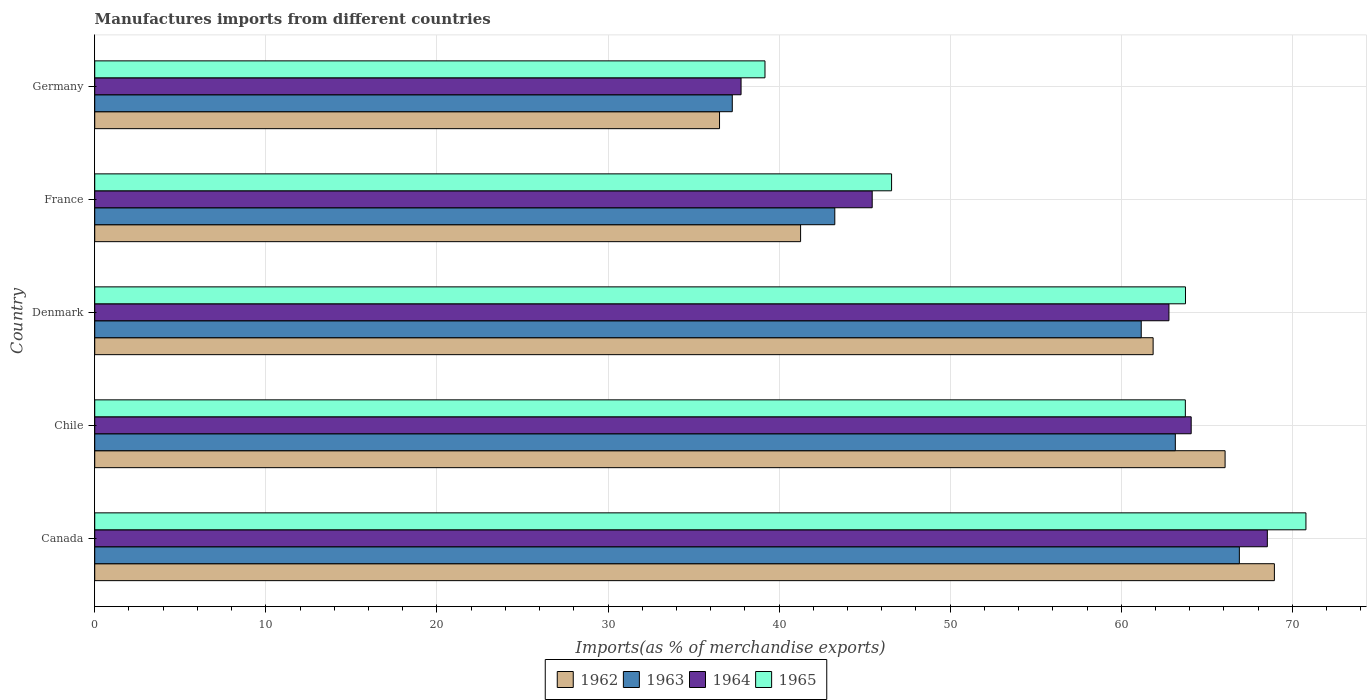How many different coloured bars are there?
Your answer should be compact. 4. Are the number of bars per tick equal to the number of legend labels?
Give a very brief answer. Yes. What is the percentage of imports to different countries in 1963 in Chile?
Your answer should be very brief. 63.16. Across all countries, what is the maximum percentage of imports to different countries in 1962?
Your answer should be very brief. 68.95. Across all countries, what is the minimum percentage of imports to different countries in 1963?
Your answer should be very brief. 37.26. In which country was the percentage of imports to different countries in 1964 minimum?
Offer a very short reply. Germany. What is the total percentage of imports to different countries in 1964 in the graph?
Your response must be concise. 278.63. What is the difference between the percentage of imports to different countries in 1962 in France and that in Germany?
Offer a terse response. 4.74. What is the difference between the percentage of imports to different countries in 1964 in France and the percentage of imports to different countries in 1963 in Denmark?
Your answer should be compact. -15.72. What is the average percentage of imports to different countries in 1964 per country?
Provide a short and direct response. 55.73. What is the difference between the percentage of imports to different countries in 1962 and percentage of imports to different countries in 1965 in France?
Give a very brief answer. -5.32. In how many countries, is the percentage of imports to different countries in 1964 greater than 70 %?
Your response must be concise. 0. What is the ratio of the percentage of imports to different countries in 1964 in Denmark to that in Germany?
Your answer should be compact. 1.66. What is the difference between the highest and the second highest percentage of imports to different countries in 1963?
Give a very brief answer. 3.74. What is the difference between the highest and the lowest percentage of imports to different countries in 1962?
Give a very brief answer. 32.43. In how many countries, is the percentage of imports to different countries in 1964 greater than the average percentage of imports to different countries in 1964 taken over all countries?
Give a very brief answer. 3. What does the 3rd bar from the top in France represents?
Ensure brevity in your answer.  1963. What does the 4th bar from the bottom in Denmark represents?
Your answer should be very brief. 1965. How many bars are there?
Offer a very short reply. 20. How many countries are there in the graph?
Provide a short and direct response. 5. Are the values on the major ticks of X-axis written in scientific E-notation?
Provide a succinct answer. No. What is the title of the graph?
Your answer should be very brief. Manufactures imports from different countries. Does "1991" appear as one of the legend labels in the graph?
Offer a very short reply. No. What is the label or title of the X-axis?
Ensure brevity in your answer.  Imports(as % of merchandise exports). What is the label or title of the Y-axis?
Offer a terse response. Country. What is the Imports(as % of merchandise exports) of 1962 in Canada?
Ensure brevity in your answer.  68.95. What is the Imports(as % of merchandise exports) of 1963 in Canada?
Offer a very short reply. 66.9. What is the Imports(as % of merchandise exports) in 1964 in Canada?
Your response must be concise. 68.54. What is the Imports(as % of merchandise exports) of 1965 in Canada?
Ensure brevity in your answer.  70.79. What is the Imports(as % of merchandise exports) in 1962 in Chile?
Provide a succinct answer. 66.07. What is the Imports(as % of merchandise exports) of 1963 in Chile?
Keep it short and to the point. 63.16. What is the Imports(as % of merchandise exports) in 1964 in Chile?
Your answer should be very brief. 64.09. What is the Imports(as % of merchandise exports) of 1965 in Chile?
Your answer should be compact. 63.74. What is the Imports(as % of merchandise exports) in 1962 in Denmark?
Ensure brevity in your answer.  61.86. What is the Imports(as % of merchandise exports) in 1963 in Denmark?
Make the answer very short. 61.17. What is the Imports(as % of merchandise exports) in 1964 in Denmark?
Your answer should be compact. 62.79. What is the Imports(as % of merchandise exports) in 1965 in Denmark?
Keep it short and to the point. 63.75. What is the Imports(as % of merchandise exports) in 1962 in France?
Ensure brevity in your answer.  41.26. What is the Imports(as % of merchandise exports) of 1963 in France?
Provide a succinct answer. 43.26. What is the Imports(as % of merchandise exports) in 1964 in France?
Your response must be concise. 45.44. What is the Imports(as % of merchandise exports) in 1965 in France?
Ensure brevity in your answer.  46.57. What is the Imports(as % of merchandise exports) in 1962 in Germany?
Offer a terse response. 36.52. What is the Imports(as % of merchandise exports) of 1963 in Germany?
Offer a very short reply. 37.26. What is the Imports(as % of merchandise exports) in 1964 in Germany?
Your answer should be compact. 37.78. What is the Imports(as % of merchandise exports) of 1965 in Germany?
Give a very brief answer. 39.18. Across all countries, what is the maximum Imports(as % of merchandise exports) in 1962?
Your answer should be compact. 68.95. Across all countries, what is the maximum Imports(as % of merchandise exports) of 1963?
Your answer should be very brief. 66.9. Across all countries, what is the maximum Imports(as % of merchandise exports) in 1964?
Your response must be concise. 68.54. Across all countries, what is the maximum Imports(as % of merchandise exports) of 1965?
Give a very brief answer. 70.79. Across all countries, what is the minimum Imports(as % of merchandise exports) in 1962?
Your response must be concise. 36.52. Across all countries, what is the minimum Imports(as % of merchandise exports) of 1963?
Your response must be concise. 37.26. Across all countries, what is the minimum Imports(as % of merchandise exports) of 1964?
Keep it short and to the point. 37.78. Across all countries, what is the minimum Imports(as % of merchandise exports) in 1965?
Offer a terse response. 39.18. What is the total Imports(as % of merchandise exports) in 1962 in the graph?
Give a very brief answer. 274.65. What is the total Imports(as % of merchandise exports) of 1963 in the graph?
Your answer should be compact. 271.75. What is the total Imports(as % of merchandise exports) in 1964 in the graph?
Provide a succinct answer. 278.63. What is the total Imports(as % of merchandise exports) in 1965 in the graph?
Offer a terse response. 284.04. What is the difference between the Imports(as % of merchandise exports) of 1962 in Canada and that in Chile?
Your response must be concise. 2.88. What is the difference between the Imports(as % of merchandise exports) in 1963 in Canada and that in Chile?
Ensure brevity in your answer.  3.74. What is the difference between the Imports(as % of merchandise exports) in 1964 in Canada and that in Chile?
Ensure brevity in your answer.  4.45. What is the difference between the Imports(as % of merchandise exports) of 1965 in Canada and that in Chile?
Offer a terse response. 7.05. What is the difference between the Imports(as % of merchandise exports) of 1962 in Canada and that in Denmark?
Offer a terse response. 7.09. What is the difference between the Imports(as % of merchandise exports) of 1963 in Canada and that in Denmark?
Provide a short and direct response. 5.74. What is the difference between the Imports(as % of merchandise exports) of 1964 in Canada and that in Denmark?
Keep it short and to the point. 5.75. What is the difference between the Imports(as % of merchandise exports) of 1965 in Canada and that in Denmark?
Your answer should be compact. 7.04. What is the difference between the Imports(as % of merchandise exports) of 1962 in Canada and that in France?
Keep it short and to the point. 27.69. What is the difference between the Imports(as % of merchandise exports) in 1963 in Canada and that in France?
Provide a succinct answer. 23.65. What is the difference between the Imports(as % of merchandise exports) of 1964 in Canada and that in France?
Offer a terse response. 23.1. What is the difference between the Imports(as % of merchandise exports) of 1965 in Canada and that in France?
Your response must be concise. 24.22. What is the difference between the Imports(as % of merchandise exports) of 1962 in Canada and that in Germany?
Make the answer very short. 32.43. What is the difference between the Imports(as % of merchandise exports) in 1963 in Canada and that in Germany?
Your answer should be very brief. 29.64. What is the difference between the Imports(as % of merchandise exports) in 1964 in Canada and that in Germany?
Provide a succinct answer. 30.76. What is the difference between the Imports(as % of merchandise exports) in 1965 in Canada and that in Germany?
Offer a terse response. 31.62. What is the difference between the Imports(as % of merchandise exports) in 1962 in Chile and that in Denmark?
Your response must be concise. 4.21. What is the difference between the Imports(as % of merchandise exports) in 1963 in Chile and that in Denmark?
Ensure brevity in your answer.  1.99. What is the difference between the Imports(as % of merchandise exports) of 1964 in Chile and that in Denmark?
Offer a terse response. 1.3. What is the difference between the Imports(as % of merchandise exports) in 1965 in Chile and that in Denmark?
Your answer should be very brief. -0.01. What is the difference between the Imports(as % of merchandise exports) of 1962 in Chile and that in France?
Provide a succinct answer. 24.81. What is the difference between the Imports(as % of merchandise exports) in 1963 in Chile and that in France?
Ensure brevity in your answer.  19.9. What is the difference between the Imports(as % of merchandise exports) in 1964 in Chile and that in France?
Your response must be concise. 18.64. What is the difference between the Imports(as % of merchandise exports) of 1965 in Chile and that in France?
Your answer should be very brief. 17.17. What is the difference between the Imports(as % of merchandise exports) of 1962 in Chile and that in Germany?
Provide a short and direct response. 29.55. What is the difference between the Imports(as % of merchandise exports) in 1963 in Chile and that in Germany?
Keep it short and to the point. 25.89. What is the difference between the Imports(as % of merchandise exports) of 1964 in Chile and that in Germany?
Ensure brevity in your answer.  26.31. What is the difference between the Imports(as % of merchandise exports) in 1965 in Chile and that in Germany?
Ensure brevity in your answer.  24.57. What is the difference between the Imports(as % of merchandise exports) of 1962 in Denmark and that in France?
Ensure brevity in your answer.  20.61. What is the difference between the Imports(as % of merchandise exports) of 1963 in Denmark and that in France?
Provide a short and direct response. 17.91. What is the difference between the Imports(as % of merchandise exports) in 1964 in Denmark and that in France?
Keep it short and to the point. 17.34. What is the difference between the Imports(as % of merchandise exports) in 1965 in Denmark and that in France?
Provide a short and direct response. 17.18. What is the difference between the Imports(as % of merchandise exports) of 1962 in Denmark and that in Germany?
Offer a terse response. 25.34. What is the difference between the Imports(as % of merchandise exports) of 1963 in Denmark and that in Germany?
Keep it short and to the point. 23.9. What is the difference between the Imports(as % of merchandise exports) in 1964 in Denmark and that in Germany?
Your answer should be very brief. 25.01. What is the difference between the Imports(as % of merchandise exports) in 1965 in Denmark and that in Germany?
Provide a succinct answer. 24.58. What is the difference between the Imports(as % of merchandise exports) of 1962 in France and that in Germany?
Your response must be concise. 4.74. What is the difference between the Imports(as % of merchandise exports) in 1963 in France and that in Germany?
Offer a terse response. 5.99. What is the difference between the Imports(as % of merchandise exports) in 1964 in France and that in Germany?
Make the answer very short. 7.67. What is the difference between the Imports(as % of merchandise exports) in 1965 in France and that in Germany?
Keep it short and to the point. 7.4. What is the difference between the Imports(as % of merchandise exports) of 1962 in Canada and the Imports(as % of merchandise exports) of 1963 in Chile?
Keep it short and to the point. 5.79. What is the difference between the Imports(as % of merchandise exports) of 1962 in Canada and the Imports(as % of merchandise exports) of 1964 in Chile?
Offer a terse response. 4.86. What is the difference between the Imports(as % of merchandise exports) in 1962 in Canada and the Imports(as % of merchandise exports) in 1965 in Chile?
Offer a very short reply. 5.21. What is the difference between the Imports(as % of merchandise exports) in 1963 in Canada and the Imports(as % of merchandise exports) in 1964 in Chile?
Your answer should be very brief. 2.82. What is the difference between the Imports(as % of merchandise exports) in 1963 in Canada and the Imports(as % of merchandise exports) in 1965 in Chile?
Your answer should be very brief. 3.16. What is the difference between the Imports(as % of merchandise exports) in 1964 in Canada and the Imports(as % of merchandise exports) in 1965 in Chile?
Keep it short and to the point. 4.79. What is the difference between the Imports(as % of merchandise exports) in 1962 in Canada and the Imports(as % of merchandise exports) in 1963 in Denmark?
Provide a short and direct response. 7.78. What is the difference between the Imports(as % of merchandise exports) of 1962 in Canada and the Imports(as % of merchandise exports) of 1964 in Denmark?
Provide a short and direct response. 6.16. What is the difference between the Imports(as % of merchandise exports) of 1962 in Canada and the Imports(as % of merchandise exports) of 1965 in Denmark?
Offer a terse response. 5.2. What is the difference between the Imports(as % of merchandise exports) in 1963 in Canada and the Imports(as % of merchandise exports) in 1964 in Denmark?
Provide a short and direct response. 4.12. What is the difference between the Imports(as % of merchandise exports) of 1963 in Canada and the Imports(as % of merchandise exports) of 1965 in Denmark?
Your response must be concise. 3.15. What is the difference between the Imports(as % of merchandise exports) in 1964 in Canada and the Imports(as % of merchandise exports) in 1965 in Denmark?
Your answer should be very brief. 4.78. What is the difference between the Imports(as % of merchandise exports) in 1962 in Canada and the Imports(as % of merchandise exports) in 1963 in France?
Provide a succinct answer. 25.69. What is the difference between the Imports(as % of merchandise exports) of 1962 in Canada and the Imports(as % of merchandise exports) of 1964 in France?
Ensure brevity in your answer.  23.51. What is the difference between the Imports(as % of merchandise exports) in 1962 in Canada and the Imports(as % of merchandise exports) in 1965 in France?
Your response must be concise. 22.38. What is the difference between the Imports(as % of merchandise exports) of 1963 in Canada and the Imports(as % of merchandise exports) of 1964 in France?
Give a very brief answer. 21.46. What is the difference between the Imports(as % of merchandise exports) of 1963 in Canada and the Imports(as % of merchandise exports) of 1965 in France?
Provide a succinct answer. 20.33. What is the difference between the Imports(as % of merchandise exports) of 1964 in Canada and the Imports(as % of merchandise exports) of 1965 in France?
Your answer should be very brief. 21.96. What is the difference between the Imports(as % of merchandise exports) in 1962 in Canada and the Imports(as % of merchandise exports) in 1963 in Germany?
Your answer should be very brief. 31.69. What is the difference between the Imports(as % of merchandise exports) in 1962 in Canada and the Imports(as % of merchandise exports) in 1964 in Germany?
Provide a short and direct response. 31.17. What is the difference between the Imports(as % of merchandise exports) of 1962 in Canada and the Imports(as % of merchandise exports) of 1965 in Germany?
Your response must be concise. 29.77. What is the difference between the Imports(as % of merchandise exports) in 1963 in Canada and the Imports(as % of merchandise exports) in 1964 in Germany?
Make the answer very short. 29.13. What is the difference between the Imports(as % of merchandise exports) of 1963 in Canada and the Imports(as % of merchandise exports) of 1965 in Germany?
Ensure brevity in your answer.  27.73. What is the difference between the Imports(as % of merchandise exports) of 1964 in Canada and the Imports(as % of merchandise exports) of 1965 in Germany?
Your answer should be very brief. 29.36. What is the difference between the Imports(as % of merchandise exports) of 1962 in Chile and the Imports(as % of merchandise exports) of 1963 in Denmark?
Your answer should be compact. 4.9. What is the difference between the Imports(as % of merchandise exports) in 1962 in Chile and the Imports(as % of merchandise exports) in 1964 in Denmark?
Offer a terse response. 3.28. What is the difference between the Imports(as % of merchandise exports) in 1962 in Chile and the Imports(as % of merchandise exports) in 1965 in Denmark?
Offer a terse response. 2.31. What is the difference between the Imports(as % of merchandise exports) in 1963 in Chile and the Imports(as % of merchandise exports) in 1964 in Denmark?
Provide a succinct answer. 0.37. What is the difference between the Imports(as % of merchandise exports) of 1963 in Chile and the Imports(as % of merchandise exports) of 1965 in Denmark?
Provide a short and direct response. -0.59. What is the difference between the Imports(as % of merchandise exports) of 1964 in Chile and the Imports(as % of merchandise exports) of 1965 in Denmark?
Your response must be concise. 0.33. What is the difference between the Imports(as % of merchandise exports) of 1962 in Chile and the Imports(as % of merchandise exports) of 1963 in France?
Your answer should be compact. 22.81. What is the difference between the Imports(as % of merchandise exports) in 1962 in Chile and the Imports(as % of merchandise exports) in 1964 in France?
Your response must be concise. 20.63. What is the difference between the Imports(as % of merchandise exports) in 1962 in Chile and the Imports(as % of merchandise exports) in 1965 in France?
Give a very brief answer. 19.49. What is the difference between the Imports(as % of merchandise exports) in 1963 in Chile and the Imports(as % of merchandise exports) in 1964 in France?
Your answer should be very brief. 17.72. What is the difference between the Imports(as % of merchandise exports) of 1963 in Chile and the Imports(as % of merchandise exports) of 1965 in France?
Provide a short and direct response. 16.58. What is the difference between the Imports(as % of merchandise exports) of 1964 in Chile and the Imports(as % of merchandise exports) of 1965 in France?
Give a very brief answer. 17.51. What is the difference between the Imports(as % of merchandise exports) of 1962 in Chile and the Imports(as % of merchandise exports) of 1963 in Germany?
Make the answer very short. 28.8. What is the difference between the Imports(as % of merchandise exports) of 1962 in Chile and the Imports(as % of merchandise exports) of 1964 in Germany?
Keep it short and to the point. 28.29. What is the difference between the Imports(as % of merchandise exports) of 1962 in Chile and the Imports(as % of merchandise exports) of 1965 in Germany?
Provide a succinct answer. 26.89. What is the difference between the Imports(as % of merchandise exports) in 1963 in Chile and the Imports(as % of merchandise exports) in 1964 in Germany?
Provide a short and direct response. 25.38. What is the difference between the Imports(as % of merchandise exports) in 1963 in Chile and the Imports(as % of merchandise exports) in 1965 in Germany?
Your answer should be very brief. 23.98. What is the difference between the Imports(as % of merchandise exports) in 1964 in Chile and the Imports(as % of merchandise exports) in 1965 in Germany?
Provide a succinct answer. 24.91. What is the difference between the Imports(as % of merchandise exports) in 1962 in Denmark and the Imports(as % of merchandise exports) in 1963 in France?
Your answer should be very brief. 18.61. What is the difference between the Imports(as % of merchandise exports) in 1962 in Denmark and the Imports(as % of merchandise exports) in 1964 in France?
Keep it short and to the point. 16.42. What is the difference between the Imports(as % of merchandise exports) in 1962 in Denmark and the Imports(as % of merchandise exports) in 1965 in France?
Provide a short and direct response. 15.29. What is the difference between the Imports(as % of merchandise exports) of 1963 in Denmark and the Imports(as % of merchandise exports) of 1964 in France?
Your response must be concise. 15.72. What is the difference between the Imports(as % of merchandise exports) of 1963 in Denmark and the Imports(as % of merchandise exports) of 1965 in France?
Provide a short and direct response. 14.59. What is the difference between the Imports(as % of merchandise exports) of 1964 in Denmark and the Imports(as % of merchandise exports) of 1965 in France?
Offer a very short reply. 16.21. What is the difference between the Imports(as % of merchandise exports) in 1962 in Denmark and the Imports(as % of merchandise exports) in 1963 in Germany?
Offer a terse response. 24.6. What is the difference between the Imports(as % of merchandise exports) in 1962 in Denmark and the Imports(as % of merchandise exports) in 1964 in Germany?
Give a very brief answer. 24.08. What is the difference between the Imports(as % of merchandise exports) in 1962 in Denmark and the Imports(as % of merchandise exports) in 1965 in Germany?
Ensure brevity in your answer.  22.69. What is the difference between the Imports(as % of merchandise exports) of 1963 in Denmark and the Imports(as % of merchandise exports) of 1964 in Germany?
Ensure brevity in your answer.  23.39. What is the difference between the Imports(as % of merchandise exports) of 1963 in Denmark and the Imports(as % of merchandise exports) of 1965 in Germany?
Your answer should be compact. 21.99. What is the difference between the Imports(as % of merchandise exports) of 1964 in Denmark and the Imports(as % of merchandise exports) of 1965 in Germany?
Give a very brief answer. 23.61. What is the difference between the Imports(as % of merchandise exports) of 1962 in France and the Imports(as % of merchandise exports) of 1963 in Germany?
Make the answer very short. 3.99. What is the difference between the Imports(as % of merchandise exports) in 1962 in France and the Imports(as % of merchandise exports) in 1964 in Germany?
Your answer should be very brief. 3.48. What is the difference between the Imports(as % of merchandise exports) of 1962 in France and the Imports(as % of merchandise exports) of 1965 in Germany?
Make the answer very short. 2.08. What is the difference between the Imports(as % of merchandise exports) of 1963 in France and the Imports(as % of merchandise exports) of 1964 in Germany?
Make the answer very short. 5.48. What is the difference between the Imports(as % of merchandise exports) in 1963 in France and the Imports(as % of merchandise exports) in 1965 in Germany?
Provide a short and direct response. 4.08. What is the difference between the Imports(as % of merchandise exports) of 1964 in France and the Imports(as % of merchandise exports) of 1965 in Germany?
Offer a terse response. 6.27. What is the average Imports(as % of merchandise exports) in 1962 per country?
Give a very brief answer. 54.93. What is the average Imports(as % of merchandise exports) in 1963 per country?
Your answer should be compact. 54.35. What is the average Imports(as % of merchandise exports) of 1964 per country?
Offer a terse response. 55.73. What is the average Imports(as % of merchandise exports) in 1965 per country?
Your answer should be compact. 56.81. What is the difference between the Imports(as % of merchandise exports) in 1962 and Imports(as % of merchandise exports) in 1963 in Canada?
Provide a succinct answer. 2.05. What is the difference between the Imports(as % of merchandise exports) in 1962 and Imports(as % of merchandise exports) in 1964 in Canada?
Keep it short and to the point. 0.41. What is the difference between the Imports(as % of merchandise exports) of 1962 and Imports(as % of merchandise exports) of 1965 in Canada?
Your answer should be compact. -1.84. What is the difference between the Imports(as % of merchandise exports) of 1963 and Imports(as % of merchandise exports) of 1964 in Canada?
Your response must be concise. -1.64. What is the difference between the Imports(as % of merchandise exports) of 1963 and Imports(as % of merchandise exports) of 1965 in Canada?
Offer a very short reply. -3.89. What is the difference between the Imports(as % of merchandise exports) of 1964 and Imports(as % of merchandise exports) of 1965 in Canada?
Your answer should be compact. -2.26. What is the difference between the Imports(as % of merchandise exports) in 1962 and Imports(as % of merchandise exports) in 1963 in Chile?
Your answer should be very brief. 2.91. What is the difference between the Imports(as % of merchandise exports) in 1962 and Imports(as % of merchandise exports) in 1964 in Chile?
Provide a short and direct response. 1.98. What is the difference between the Imports(as % of merchandise exports) in 1962 and Imports(as % of merchandise exports) in 1965 in Chile?
Keep it short and to the point. 2.32. What is the difference between the Imports(as % of merchandise exports) in 1963 and Imports(as % of merchandise exports) in 1964 in Chile?
Offer a terse response. -0.93. What is the difference between the Imports(as % of merchandise exports) of 1963 and Imports(as % of merchandise exports) of 1965 in Chile?
Make the answer very short. -0.59. What is the difference between the Imports(as % of merchandise exports) of 1964 and Imports(as % of merchandise exports) of 1965 in Chile?
Your response must be concise. 0.34. What is the difference between the Imports(as % of merchandise exports) of 1962 and Imports(as % of merchandise exports) of 1963 in Denmark?
Your answer should be very brief. 0.69. What is the difference between the Imports(as % of merchandise exports) in 1962 and Imports(as % of merchandise exports) in 1964 in Denmark?
Ensure brevity in your answer.  -0.92. What is the difference between the Imports(as % of merchandise exports) in 1962 and Imports(as % of merchandise exports) in 1965 in Denmark?
Keep it short and to the point. -1.89. What is the difference between the Imports(as % of merchandise exports) of 1963 and Imports(as % of merchandise exports) of 1964 in Denmark?
Keep it short and to the point. -1.62. What is the difference between the Imports(as % of merchandise exports) in 1963 and Imports(as % of merchandise exports) in 1965 in Denmark?
Your response must be concise. -2.59. What is the difference between the Imports(as % of merchandise exports) of 1964 and Imports(as % of merchandise exports) of 1965 in Denmark?
Provide a succinct answer. -0.97. What is the difference between the Imports(as % of merchandise exports) of 1962 and Imports(as % of merchandise exports) of 1963 in France?
Your response must be concise. -2. What is the difference between the Imports(as % of merchandise exports) in 1962 and Imports(as % of merchandise exports) in 1964 in France?
Your answer should be compact. -4.19. What is the difference between the Imports(as % of merchandise exports) of 1962 and Imports(as % of merchandise exports) of 1965 in France?
Provide a succinct answer. -5.32. What is the difference between the Imports(as % of merchandise exports) in 1963 and Imports(as % of merchandise exports) in 1964 in France?
Keep it short and to the point. -2.19. What is the difference between the Imports(as % of merchandise exports) of 1963 and Imports(as % of merchandise exports) of 1965 in France?
Keep it short and to the point. -3.32. What is the difference between the Imports(as % of merchandise exports) of 1964 and Imports(as % of merchandise exports) of 1965 in France?
Provide a short and direct response. -1.13. What is the difference between the Imports(as % of merchandise exports) of 1962 and Imports(as % of merchandise exports) of 1963 in Germany?
Offer a terse response. -0.75. What is the difference between the Imports(as % of merchandise exports) of 1962 and Imports(as % of merchandise exports) of 1964 in Germany?
Offer a very short reply. -1.26. What is the difference between the Imports(as % of merchandise exports) in 1962 and Imports(as % of merchandise exports) in 1965 in Germany?
Keep it short and to the point. -2.66. What is the difference between the Imports(as % of merchandise exports) of 1963 and Imports(as % of merchandise exports) of 1964 in Germany?
Offer a terse response. -0.51. What is the difference between the Imports(as % of merchandise exports) of 1963 and Imports(as % of merchandise exports) of 1965 in Germany?
Provide a short and direct response. -1.91. What is the difference between the Imports(as % of merchandise exports) in 1964 and Imports(as % of merchandise exports) in 1965 in Germany?
Provide a short and direct response. -1.4. What is the ratio of the Imports(as % of merchandise exports) of 1962 in Canada to that in Chile?
Offer a terse response. 1.04. What is the ratio of the Imports(as % of merchandise exports) in 1963 in Canada to that in Chile?
Your answer should be compact. 1.06. What is the ratio of the Imports(as % of merchandise exports) in 1964 in Canada to that in Chile?
Give a very brief answer. 1.07. What is the ratio of the Imports(as % of merchandise exports) in 1965 in Canada to that in Chile?
Your response must be concise. 1.11. What is the ratio of the Imports(as % of merchandise exports) in 1962 in Canada to that in Denmark?
Provide a short and direct response. 1.11. What is the ratio of the Imports(as % of merchandise exports) in 1963 in Canada to that in Denmark?
Your answer should be very brief. 1.09. What is the ratio of the Imports(as % of merchandise exports) of 1964 in Canada to that in Denmark?
Keep it short and to the point. 1.09. What is the ratio of the Imports(as % of merchandise exports) of 1965 in Canada to that in Denmark?
Ensure brevity in your answer.  1.11. What is the ratio of the Imports(as % of merchandise exports) in 1962 in Canada to that in France?
Your answer should be very brief. 1.67. What is the ratio of the Imports(as % of merchandise exports) in 1963 in Canada to that in France?
Provide a succinct answer. 1.55. What is the ratio of the Imports(as % of merchandise exports) of 1964 in Canada to that in France?
Keep it short and to the point. 1.51. What is the ratio of the Imports(as % of merchandise exports) in 1965 in Canada to that in France?
Give a very brief answer. 1.52. What is the ratio of the Imports(as % of merchandise exports) in 1962 in Canada to that in Germany?
Give a very brief answer. 1.89. What is the ratio of the Imports(as % of merchandise exports) of 1963 in Canada to that in Germany?
Make the answer very short. 1.8. What is the ratio of the Imports(as % of merchandise exports) in 1964 in Canada to that in Germany?
Ensure brevity in your answer.  1.81. What is the ratio of the Imports(as % of merchandise exports) of 1965 in Canada to that in Germany?
Offer a terse response. 1.81. What is the ratio of the Imports(as % of merchandise exports) of 1962 in Chile to that in Denmark?
Ensure brevity in your answer.  1.07. What is the ratio of the Imports(as % of merchandise exports) in 1963 in Chile to that in Denmark?
Ensure brevity in your answer.  1.03. What is the ratio of the Imports(as % of merchandise exports) in 1964 in Chile to that in Denmark?
Keep it short and to the point. 1.02. What is the ratio of the Imports(as % of merchandise exports) of 1965 in Chile to that in Denmark?
Give a very brief answer. 1. What is the ratio of the Imports(as % of merchandise exports) of 1962 in Chile to that in France?
Ensure brevity in your answer.  1.6. What is the ratio of the Imports(as % of merchandise exports) in 1963 in Chile to that in France?
Give a very brief answer. 1.46. What is the ratio of the Imports(as % of merchandise exports) in 1964 in Chile to that in France?
Ensure brevity in your answer.  1.41. What is the ratio of the Imports(as % of merchandise exports) in 1965 in Chile to that in France?
Give a very brief answer. 1.37. What is the ratio of the Imports(as % of merchandise exports) of 1962 in Chile to that in Germany?
Give a very brief answer. 1.81. What is the ratio of the Imports(as % of merchandise exports) in 1963 in Chile to that in Germany?
Your response must be concise. 1.69. What is the ratio of the Imports(as % of merchandise exports) of 1964 in Chile to that in Germany?
Make the answer very short. 1.7. What is the ratio of the Imports(as % of merchandise exports) of 1965 in Chile to that in Germany?
Give a very brief answer. 1.63. What is the ratio of the Imports(as % of merchandise exports) of 1962 in Denmark to that in France?
Provide a short and direct response. 1.5. What is the ratio of the Imports(as % of merchandise exports) of 1963 in Denmark to that in France?
Your response must be concise. 1.41. What is the ratio of the Imports(as % of merchandise exports) of 1964 in Denmark to that in France?
Keep it short and to the point. 1.38. What is the ratio of the Imports(as % of merchandise exports) in 1965 in Denmark to that in France?
Make the answer very short. 1.37. What is the ratio of the Imports(as % of merchandise exports) of 1962 in Denmark to that in Germany?
Give a very brief answer. 1.69. What is the ratio of the Imports(as % of merchandise exports) in 1963 in Denmark to that in Germany?
Give a very brief answer. 1.64. What is the ratio of the Imports(as % of merchandise exports) of 1964 in Denmark to that in Germany?
Ensure brevity in your answer.  1.66. What is the ratio of the Imports(as % of merchandise exports) in 1965 in Denmark to that in Germany?
Give a very brief answer. 1.63. What is the ratio of the Imports(as % of merchandise exports) of 1962 in France to that in Germany?
Give a very brief answer. 1.13. What is the ratio of the Imports(as % of merchandise exports) of 1963 in France to that in Germany?
Your answer should be compact. 1.16. What is the ratio of the Imports(as % of merchandise exports) of 1964 in France to that in Germany?
Your answer should be compact. 1.2. What is the ratio of the Imports(as % of merchandise exports) in 1965 in France to that in Germany?
Your answer should be very brief. 1.19. What is the difference between the highest and the second highest Imports(as % of merchandise exports) in 1962?
Make the answer very short. 2.88. What is the difference between the highest and the second highest Imports(as % of merchandise exports) of 1963?
Offer a very short reply. 3.74. What is the difference between the highest and the second highest Imports(as % of merchandise exports) in 1964?
Make the answer very short. 4.45. What is the difference between the highest and the second highest Imports(as % of merchandise exports) in 1965?
Your answer should be compact. 7.04. What is the difference between the highest and the lowest Imports(as % of merchandise exports) of 1962?
Offer a terse response. 32.43. What is the difference between the highest and the lowest Imports(as % of merchandise exports) in 1963?
Your response must be concise. 29.64. What is the difference between the highest and the lowest Imports(as % of merchandise exports) in 1964?
Your answer should be very brief. 30.76. What is the difference between the highest and the lowest Imports(as % of merchandise exports) of 1965?
Keep it short and to the point. 31.62. 